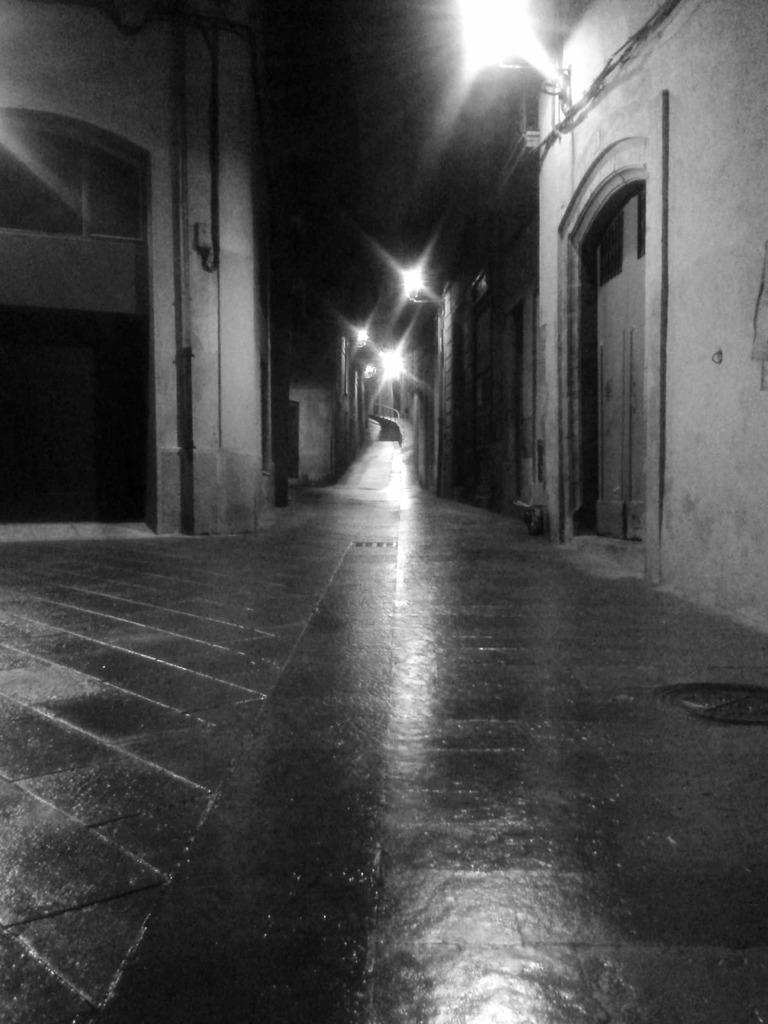What can be seen in the image in terms of structures? There are many buildings in the image. Can you describe the doors visible in the image? There is a door on the right side of the image and another door on the left side of the image. What type of illumination is present in the image? There are lights on the wall in the image. How would you describe the lighting conditions at the top of the image? The top of the image appears to be dark. What type of beef can be seen in the can on the left side of the image? There is no beef or can present in the image; it features many buildings, doors, lights, and a dark top portion. Can you describe the tooth that is hanging from the door on the right side of the image? There is no tooth present on the door or anywhere else in the image. 